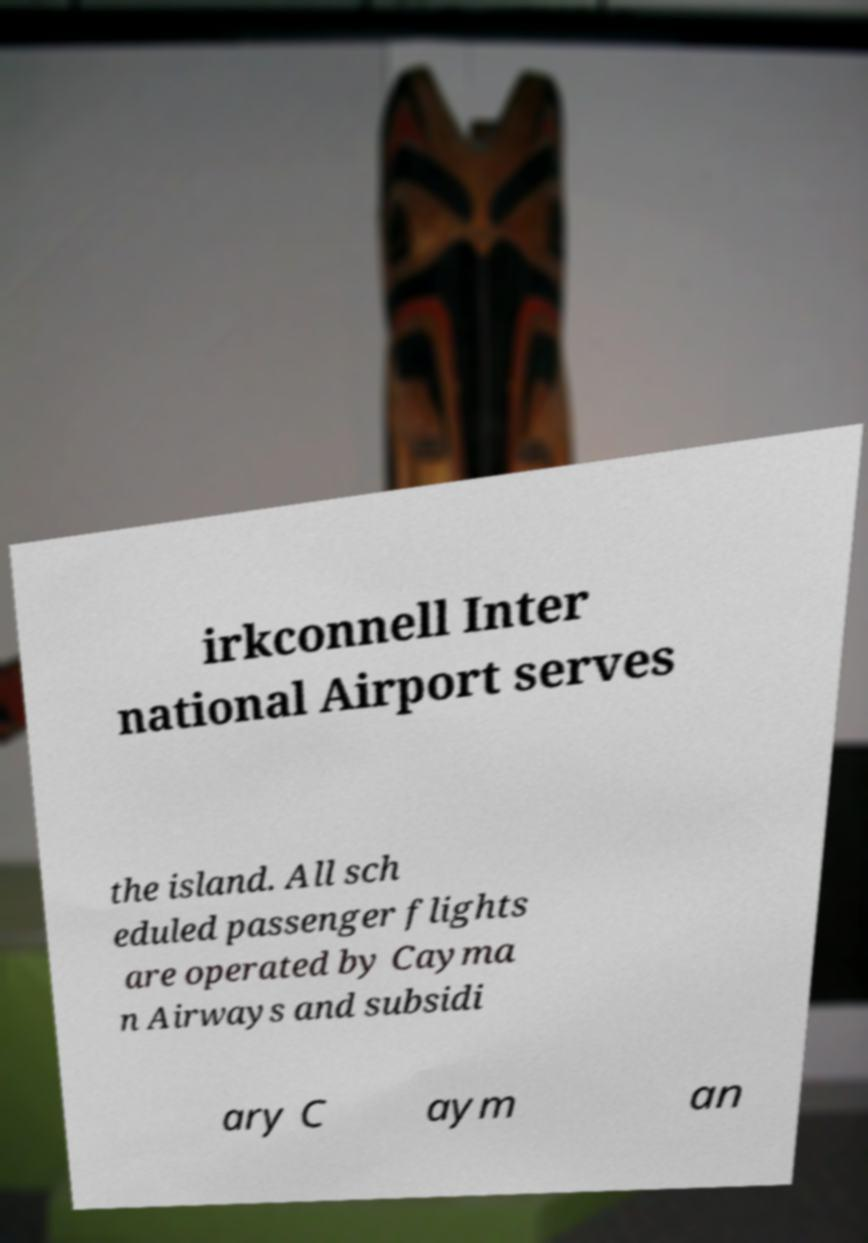Please identify and transcribe the text found in this image. irkconnell Inter national Airport serves the island. All sch eduled passenger flights are operated by Cayma n Airways and subsidi ary C aym an 